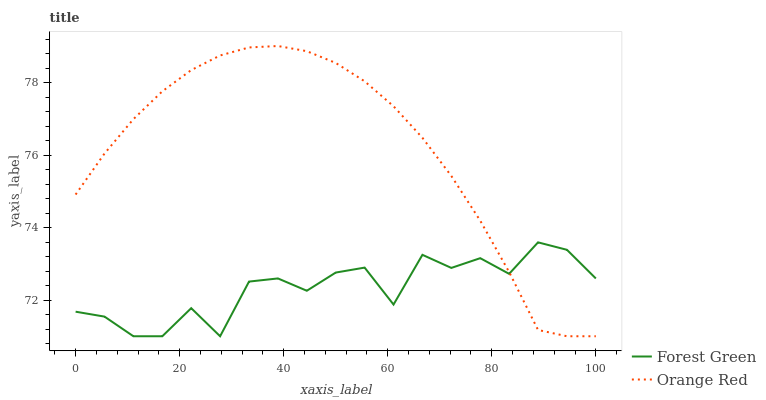Does Orange Red have the minimum area under the curve?
Answer yes or no. No. Is Orange Red the roughest?
Answer yes or no. No. 